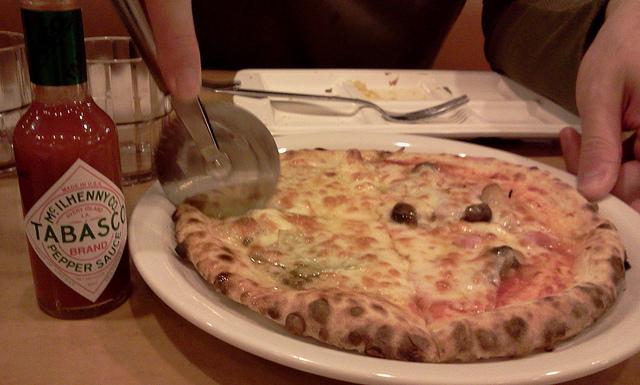What is the pizza on?
Answer briefly. Plate. What condiments are on the table?
Keep it brief. Tabasco. What is the person cutting?
Write a very short answer. Pizza. What is the stuff in the bottle for?
Quick response, please. Tabasco sauce. 